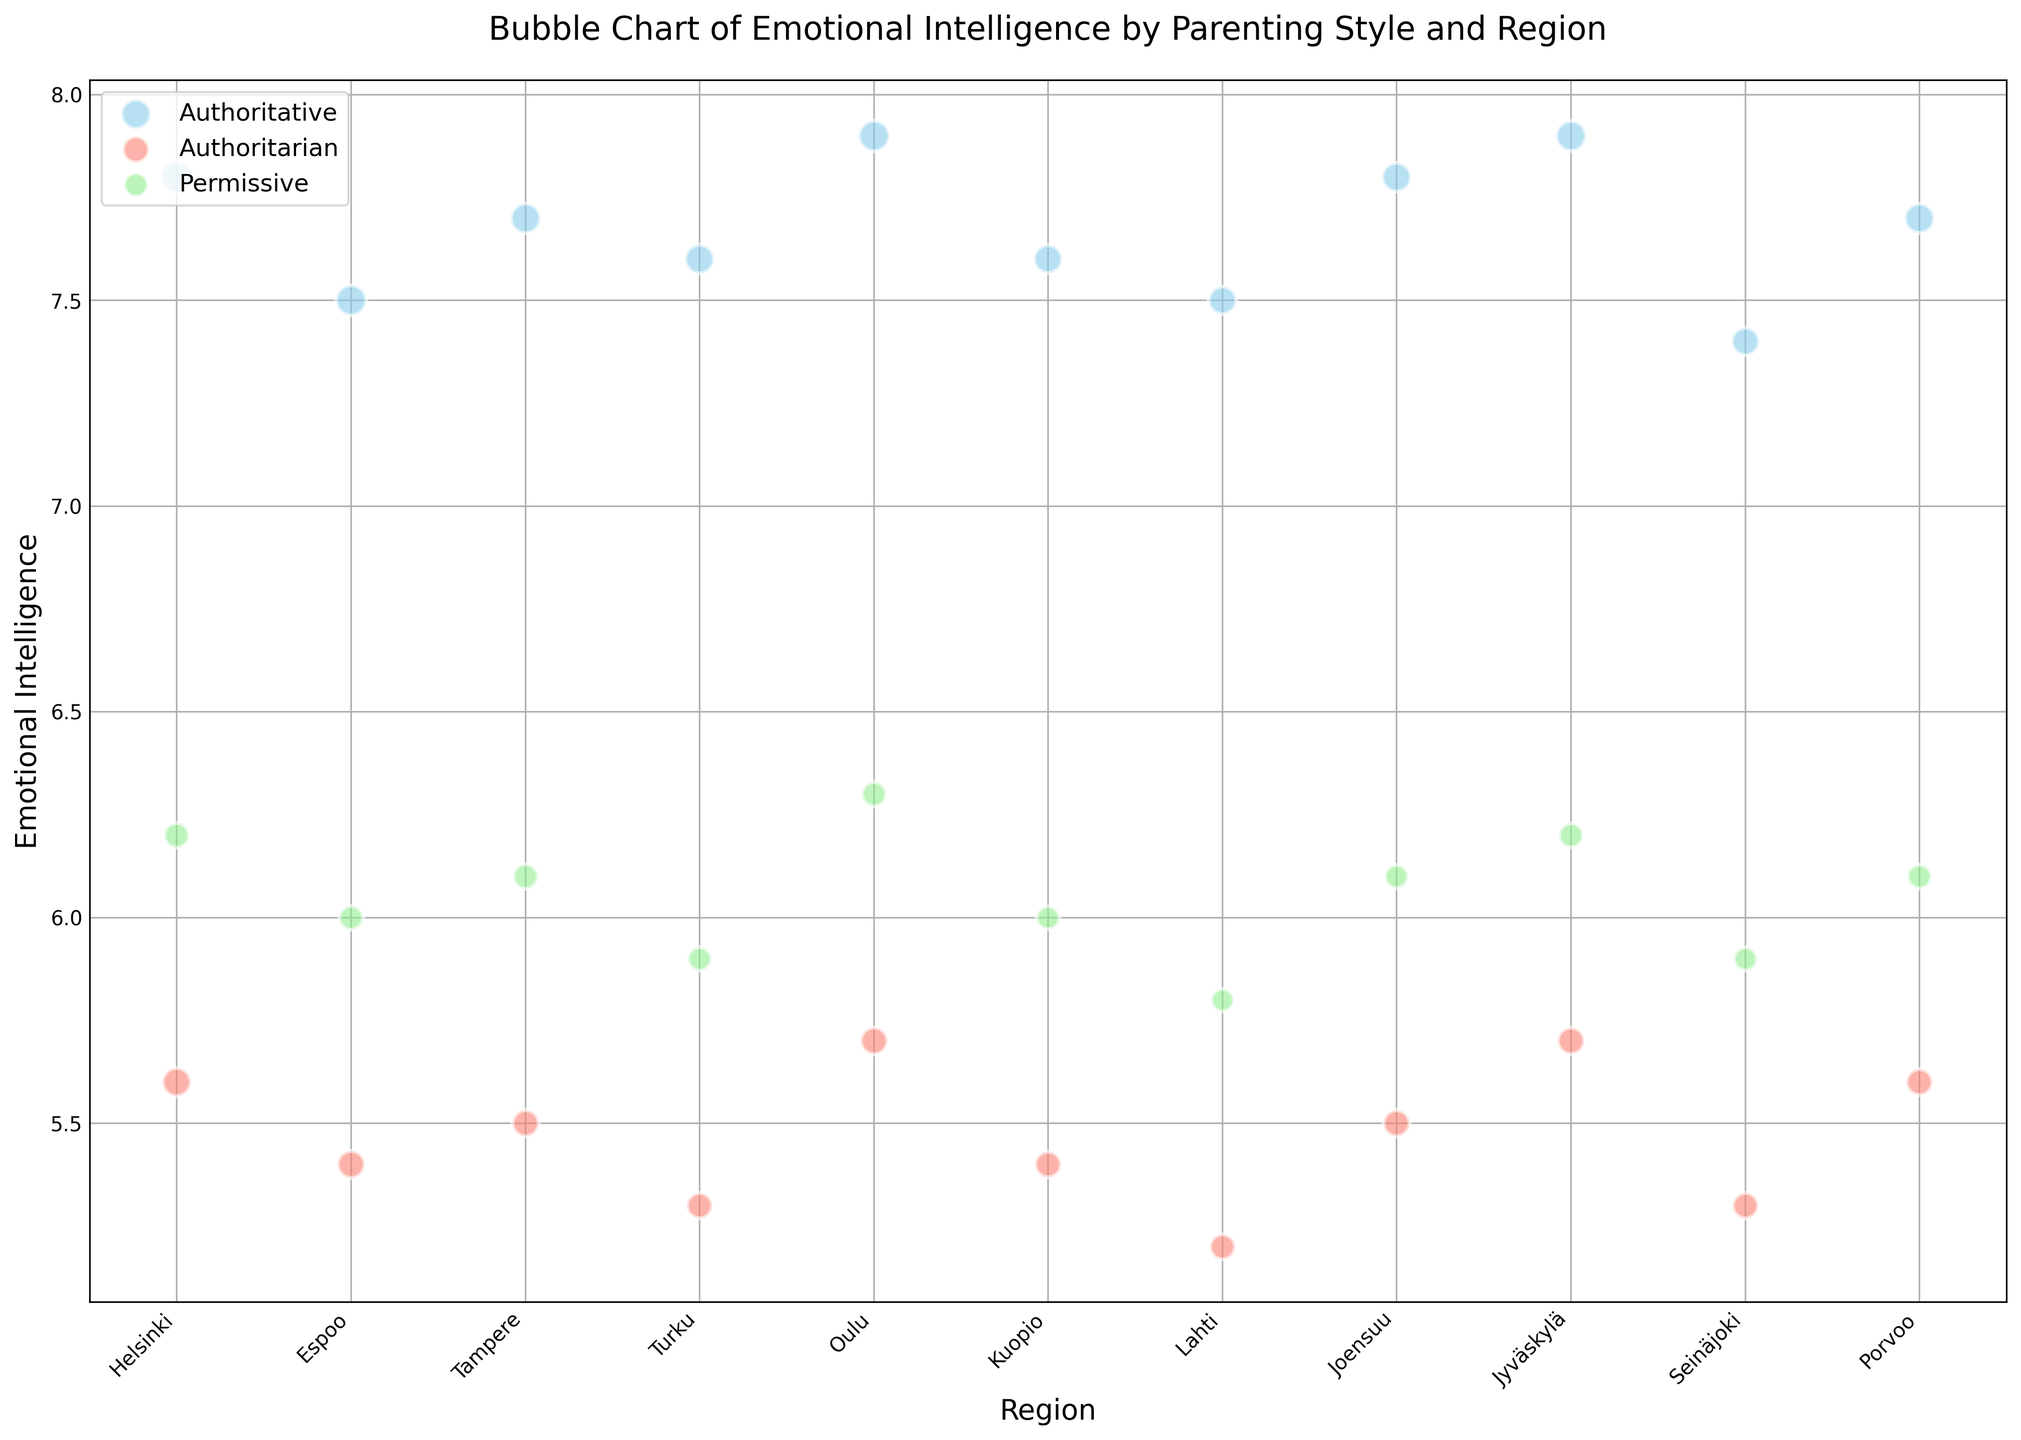Which region has the highest emotional intelligence for Authoritative parenting style? Look at the bubbles representing the Authoritative parenting style, identify which region has the highest position on the y-axis (Emotional Intelligence).
Answer: Oulu and Jyväskylä What is the difference in emotional intelligence between Authoritative and Authoritarian parenting styles in Helsinki? Identify the y-axis positions of bubbles for Authoritative and Authoritarian parenting styles in Helsinki, and subtract the value for Authoritarian from the value for Authoritative.
Answer: 2.2 In which region does the Permissive parenting style have the lowest emotional intelligence? Look at the bubbles corresponding to the Permissive parenting style and identify the region where the bubble is at the lowest position on the y-axis.
Answer: Lahti Compare the size of the bubbles for Authoritative and Permissive parenting styles in Turku. Which style has more respondents? Compare the sizes of the bubbles for both parenting styles in Turku. The larger bubble represents more respondents.
Answer: Authoritative How many respondents in total participated from Joensuu across all parenting styles? Add the number of respondents from Joensuu for Authoritative, Authoritarian, and Permissive parenting styles.
Answer: 251 Which region has the smallest difference in emotional intelligence between Authoritative and Permissive parenting styles? Calculate the differences between emotional intelligence scores of Authoritative and Permissive styles for each region, and identify the smallest value.
Answer: Espoo What is the overall trend in emotional intelligence among the different parenting styles? Observe the general positioning of bubbles by color: skyblue (Authoritative), salmon (Authoritarian), and lightgreen (Permissive). Typically, Authoritative is highest, followed by Permissive, then Authoritarian.
Answer: Authoritative > Permissive > Authoritarian Is there any region where the Permissive parenting style has a higher emotional intelligence than the Authoritative style? Look at the y-axis positions of the bubbles for each region and compare if any Permissive bubble is higher than the corresponding Authoritative bubble.
Answer: No What is the average emotional intelligence for the Authoritarian parenting style across all regions? Sum the emotional intelligence values for the Authoritarian parenting style across all regions and divide by the number of regions.
Answer: 5.5 